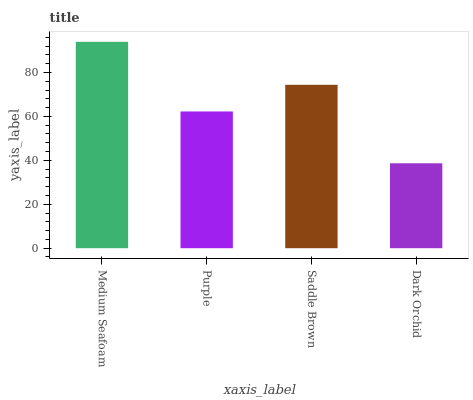Is Dark Orchid the minimum?
Answer yes or no. Yes. Is Medium Seafoam the maximum?
Answer yes or no. Yes. Is Purple the minimum?
Answer yes or no. No. Is Purple the maximum?
Answer yes or no. No. Is Medium Seafoam greater than Purple?
Answer yes or no. Yes. Is Purple less than Medium Seafoam?
Answer yes or no. Yes. Is Purple greater than Medium Seafoam?
Answer yes or no. No. Is Medium Seafoam less than Purple?
Answer yes or no. No. Is Saddle Brown the high median?
Answer yes or no. Yes. Is Purple the low median?
Answer yes or no. Yes. Is Purple the high median?
Answer yes or no. No. Is Dark Orchid the low median?
Answer yes or no. No. 